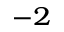<formula> <loc_0><loc_0><loc_500><loc_500>^ { - 2 }</formula> 